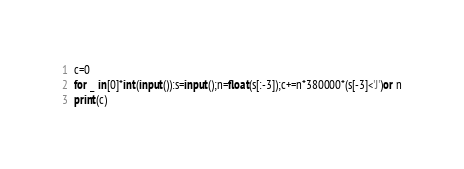Convert code to text. <code><loc_0><loc_0><loc_500><loc_500><_Python_>c=0
for _ in[0]*int(input()):s=input();n=float(s[:-3]);c+=n*380000*(s[-3]<'J')or n
print(c)</code> 